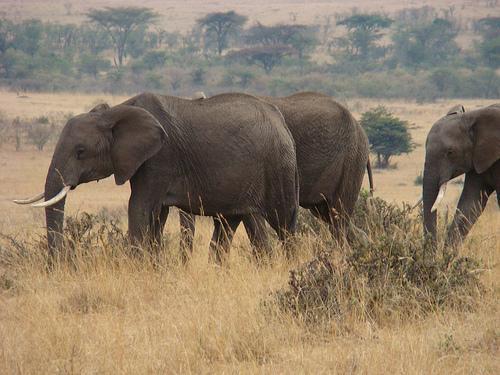How many elephants are pictured?
Give a very brief answer. 3. How many tusks are pictured?
Give a very brief answer. 4. 